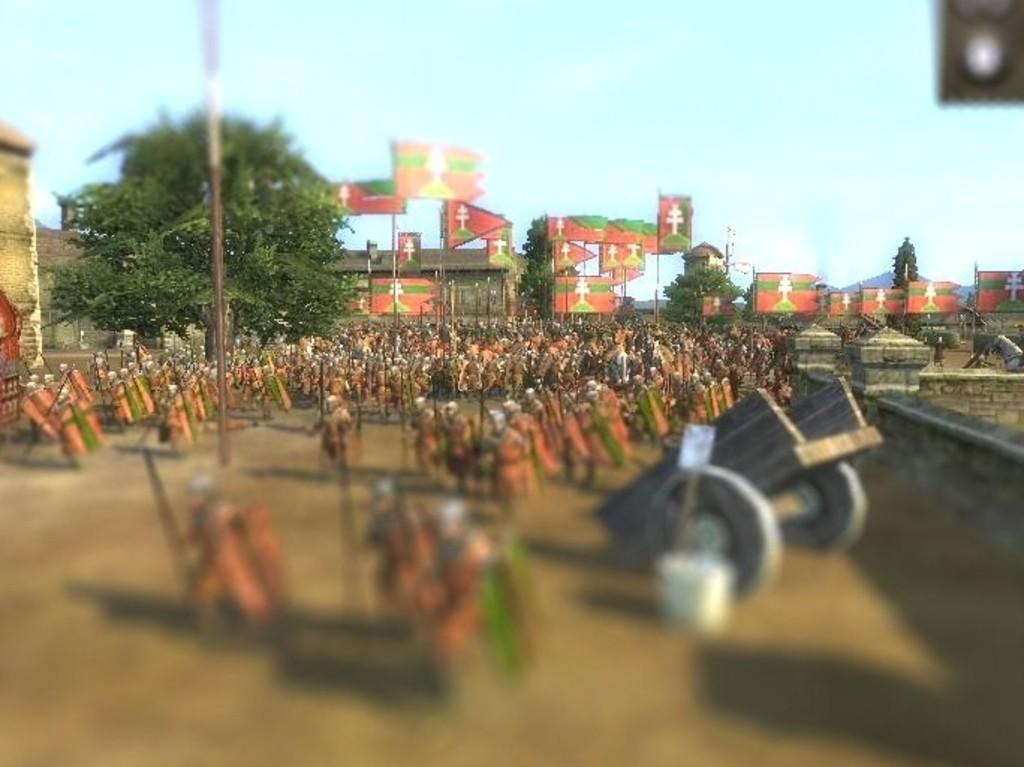Can you describe this image briefly? In this image we can see a group of people standing on the surface holding the shields and some weapons. On the right side we can see a cart, a board with a stand and a container beside them. We can also see some poles, the flags, boards, some houses, trees and the sky which looks cloudy. 